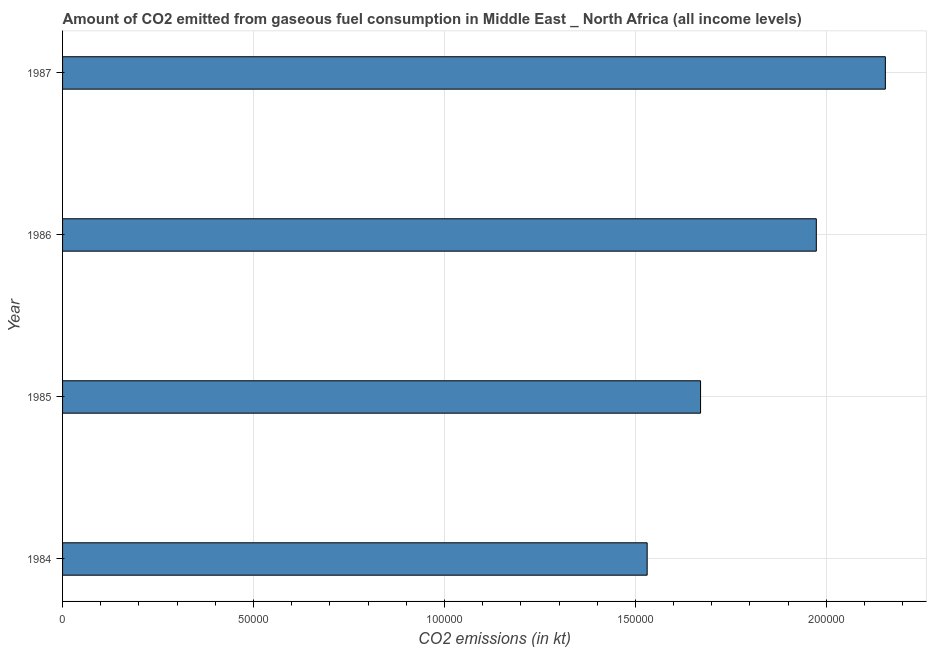Does the graph contain any zero values?
Offer a very short reply. No. Does the graph contain grids?
Offer a terse response. Yes. What is the title of the graph?
Offer a terse response. Amount of CO2 emitted from gaseous fuel consumption in Middle East _ North Africa (all income levels). What is the label or title of the X-axis?
Provide a short and direct response. CO2 emissions (in kt). What is the co2 emissions from gaseous fuel consumption in 1986?
Your answer should be compact. 1.97e+05. Across all years, what is the maximum co2 emissions from gaseous fuel consumption?
Keep it short and to the point. 2.15e+05. Across all years, what is the minimum co2 emissions from gaseous fuel consumption?
Your response must be concise. 1.53e+05. In which year was the co2 emissions from gaseous fuel consumption maximum?
Ensure brevity in your answer.  1987. In which year was the co2 emissions from gaseous fuel consumption minimum?
Offer a terse response. 1984. What is the sum of the co2 emissions from gaseous fuel consumption?
Keep it short and to the point. 7.33e+05. What is the difference between the co2 emissions from gaseous fuel consumption in 1985 and 1987?
Make the answer very short. -4.84e+04. What is the average co2 emissions from gaseous fuel consumption per year?
Your answer should be compact. 1.83e+05. What is the median co2 emissions from gaseous fuel consumption?
Your answer should be compact. 1.82e+05. What is the ratio of the co2 emissions from gaseous fuel consumption in 1984 to that in 1987?
Your answer should be very brief. 0.71. Is the co2 emissions from gaseous fuel consumption in 1986 less than that in 1987?
Offer a very short reply. Yes. What is the difference between the highest and the second highest co2 emissions from gaseous fuel consumption?
Keep it short and to the point. 1.81e+04. Is the sum of the co2 emissions from gaseous fuel consumption in 1985 and 1987 greater than the maximum co2 emissions from gaseous fuel consumption across all years?
Ensure brevity in your answer.  Yes. What is the difference between the highest and the lowest co2 emissions from gaseous fuel consumption?
Your answer should be very brief. 6.24e+04. In how many years, is the co2 emissions from gaseous fuel consumption greater than the average co2 emissions from gaseous fuel consumption taken over all years?
Give a very brief answer. 2. How many bars are there?
Give a very brief answer. 4. Are all the bars in the graph horizontal?
Provide a short and direct response. Yes. What is the difference between two consecutive major ticks on the X-axis?
Make the answer very short. 5.00e+04. What is the CO2 emissions (in kt) in 1984?
Your answer should be very brief. 1.53e+05. What is the CO2 emissions (in kt) in 1985?
Keep it short and to the point. 1.67e+05. What is the CO2 emissions (in kt) in 1986?
Ensure brevity in your answer.  1.97e+05. What is the CO2 emissions (in kt) of 1987?
Your answer should be very brief. 2.15e+05. What is the difference between the CO2 emissions (in kt) in 1984 and 1985?
Give a very brief answer. -1.40e+04. What is the difference between the CO2 emissions (in kt) in 1984 and 1986?
Ensure brevity in your answer.  -4.43e+04. What is the difference between the CO2 emissions (in kt) in 1984 and 1987?
Provide a short and direct response. -6.24e+04. What is the difference between the CO2 emissions (in kt) in 1985 and 1986?
Your answer should be very brief. -3.03e+04. What is the difference between the CO2 emissions (in kt) in 1985 and 1987?
Offer a terse response. -4.84e+04. What is the difference between the CO2 emissions (in kt) in 1986 and 1987?
Keep it short and to the point. -1.81e+04. What is the ratio of the CO2 emissions (in kt) in 1984 to that in 1985?
Make the answer very short. 0.92. What is the ratio of the CO2 emissions (in kt) in 1984 to that in 1986?
Your response must be concise. 0.78. What is the ratio of the CO2 emissions (in kt) in 1984 to that in 1987?
Your answer should be compact. 0.71. What is the ratio of the CO2 emissions (in kt) in 1985 to that in 1986?
Offer a terse response. 0.85. What is the ratio of the CO2 emissions (in kt) in 1985 to that in 1987?
Provide a succinct answer. 0.78. What is the ratio of the CO2 emissions (in kt) in 1986 to that in 1987?
Provide a short and direct response. 0.92. 